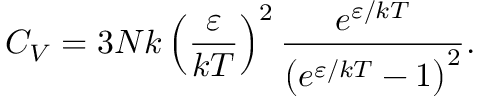Convert formula to latex. <formula><loc_0><loc_0><loc_500><loc_500>C _ { V } = 3 N k \left ( { \frac { \varepsilon } { k T } } \right ) ^ { 2 } { \frac { e ^ { \varepsilon / k T } } { \left ( e ^ { \varepsilon / k T } - 1 \right ) ^ { 2 } } } .</formula> 